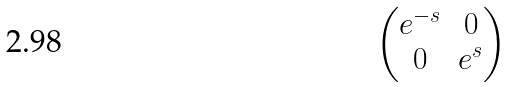Convert formula to latex. <formula><loc_0><loc_0><loc_500><loc_500>\begin{pmatrix} e ^ { - s } & 0 \\ 0 & e ^ { s } \end{pmatrix}</formula> 